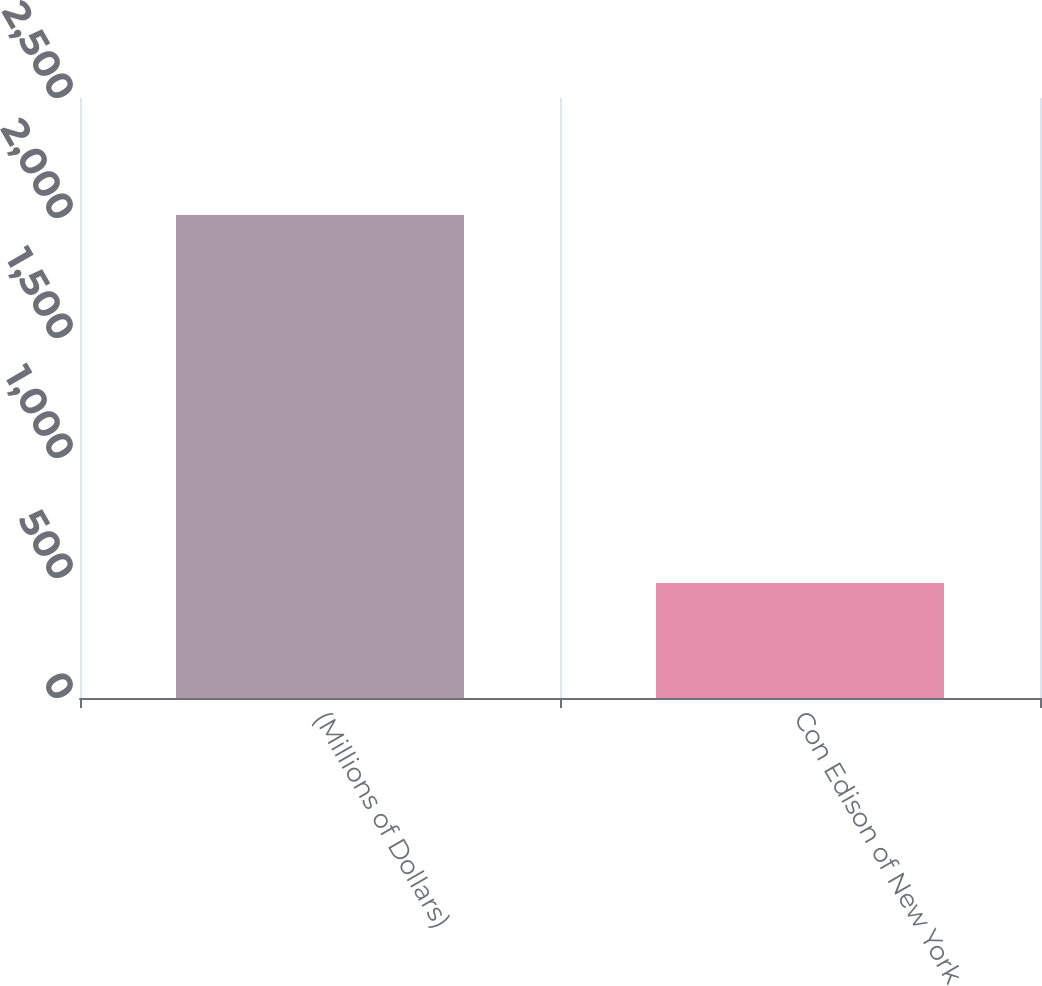Convert chart. <chart><loc_0><loc_0><loc_500><loc_500><bar_chart><fcel>(Millions of Dollars)<fcel>Con Edison of New York<nl><fcel>2012<fcel>479<nl></chart> 